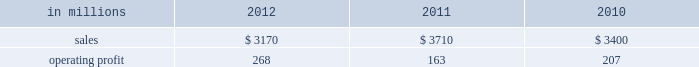Freesheet paper were higher in russia , but lower in europe reflecting weak economic conditions and market demand .
Average sales price realizations for pulp decreased .
Lower input costs for wood and purchased fiber were partially offset by higher costs for energy , chemicals and packaging .
Freight costs were also higher .
Planned maintenance downtime costs were higher due to executing a significant once-every-ten-years maintenance outage plus the regularly scheduled 18-month outage at the saillat mill while outage costs in russia and poland were lower .
Manufacturing operating costs were favor- entering 2013 , sales volumes in the first quarter are expected to be seasonally weaker in russia , but about flat in europe .
Average sales price realizations for uncoated freesheet paper are expected to decrease in europe , but increase in russia .
Input costs should be higher in russia , especially for wood and energy , but be slightly lower in europe .
No maintenance outages are scheduled for the first quarter .
Ind ian papers includes the results of andhra pradesh paper mills ( appm ) of which a 75% ( 75 % ) interest was acquired on october 14 , 2011 .
Net sales were $ 185 million in 2012 and $ 35 million in 2011 .
Operat- ing profits were a loss of $ 16 million in 2012 and a loss of $ 3 million in 2011 .
Asian pr int ing papers net sales were $ 85 mil- lion in 2012 , $ 75 million in 2011 and $ 80 million in 2010 .
Operating profits were improved from break- even in past years to $ 1 million in 2012 .
U.s .
Pulp net sales were $ 725 million in 2012 compared with $ 725 million in 2011 and $ 715 million in 2010 .
Operating profits were a loss of $ 59 million in 2012 compared with gains of $ 87 million in 2011 and $ 107 million in 2010 .
Sales volumes in 2012 increased from 2011 primarily due to the start-up of pulp production at the franklin mill in the third quarter of 2012 .
Average sales price realizations were significantly lower for both fluff pulp and market pulp .
Input costs were lower , primarily for wood and energy .
Freight costs were slightly lower .
Mill operating costs were unfavorable primarily due to costs associated with the start-up of the franklin mill .
Planned maintenance downtime costs were lower .
In the first quarter of 2013 , sales volumes are expected to be flat with the fourth quarter of 2012 .
Average sales price realizations are expected to improve reflecting the realization of sales price increases for paper and tissue pulp that were announced in the fourth quarter of 2012 .
Input costs should be flat .
Planned maintenance downtime costs should be about $ 9 million higher than in the fourth quarter of 2012 .
Manufacturing costs related to the franklin mill should be lower as we continue to improve operations .
Consumer packaging demand and pricing for consumer packaging prod- ucts correlate closely with consumer spending and general economic activity .
In addition to prices and volumes , major factors affecting the profitability of consumer packaging are raw material and energy costs , freight costs , manufacturing efficiency and product mix .
Consumer packaging net sales in 2012 decreased 15% ( 15 % ) from 2011 and 7% ( 7 % ) from 2010 .
Operating profits increased 64% ( 64 % ) from 2011 and 29% ( 29 % ) from 2010 .
Net sales and operating profits include the shorewood business in 2011 and 2010 .
Exclud- ing asset impairment and other charges associated with the sale of the shorewood business , and facility closure costs , 2012 operating profits were 27% ( 27 % ) lower than in 2011 , but 23% ( 23 % ) higher than in 2010 .
Benefits from lower raw material costs ( $ 22 million ) , lower maintenance outage costs ( $ 5 million ) and other items ( $ 2 million ) were more than offset by lower sales price realizations and an unfavorable product mix ( $ 66 million ) , lower sales volumes and increased market-related downtime ( $ 22 million ) , and higher operating costs ( $ 40 million ) .
In addition , operating profits in 2012 included a gain of $ 3 million related to the sale of the shorewood business while operating profits in 2011 included a $ 129 million fixed asset impairment charge for the north ameri- can shorewood business and $ 72 million for other charges associated with the sale of the shorewood business .
Consumer packaging .
North american consumer packaging net sales were $ 2.0 billion in 2012 compared with $ 2.5 billion in 2011 and $ 2.4 billion in 2010 .
Operating profits were $ 165 million ( $ 162 million excluding a gain related to the sale of the shorewood business ) in 2012 compared with $ 35 million ( $ 236 million excluding asset impairment and other charges asso- ciated with the sale of the shorewood business ) in 2011 and $ 97 million ( $ 105 million excluding facility closure costs ) in 2010 .
Coated paperboard sales volumes in 2012 were lower than in 2011 reflecting weaker market demand .
Average sales price realizations were lower , primar- ily for folding carton board .
Input costs for wood increased , but were partially offset by lower costs for chemicals and energy .
Planned maintenance down- time costs were slightly lower .
Market-related down- time was about 113000 tons in 2012 compared with about 38000 tons in 2011. .
What was the average net sales in 2011 and 2012 in millions? 
Computations: ((185 + 35) / 2)
Answer: 110.0. 